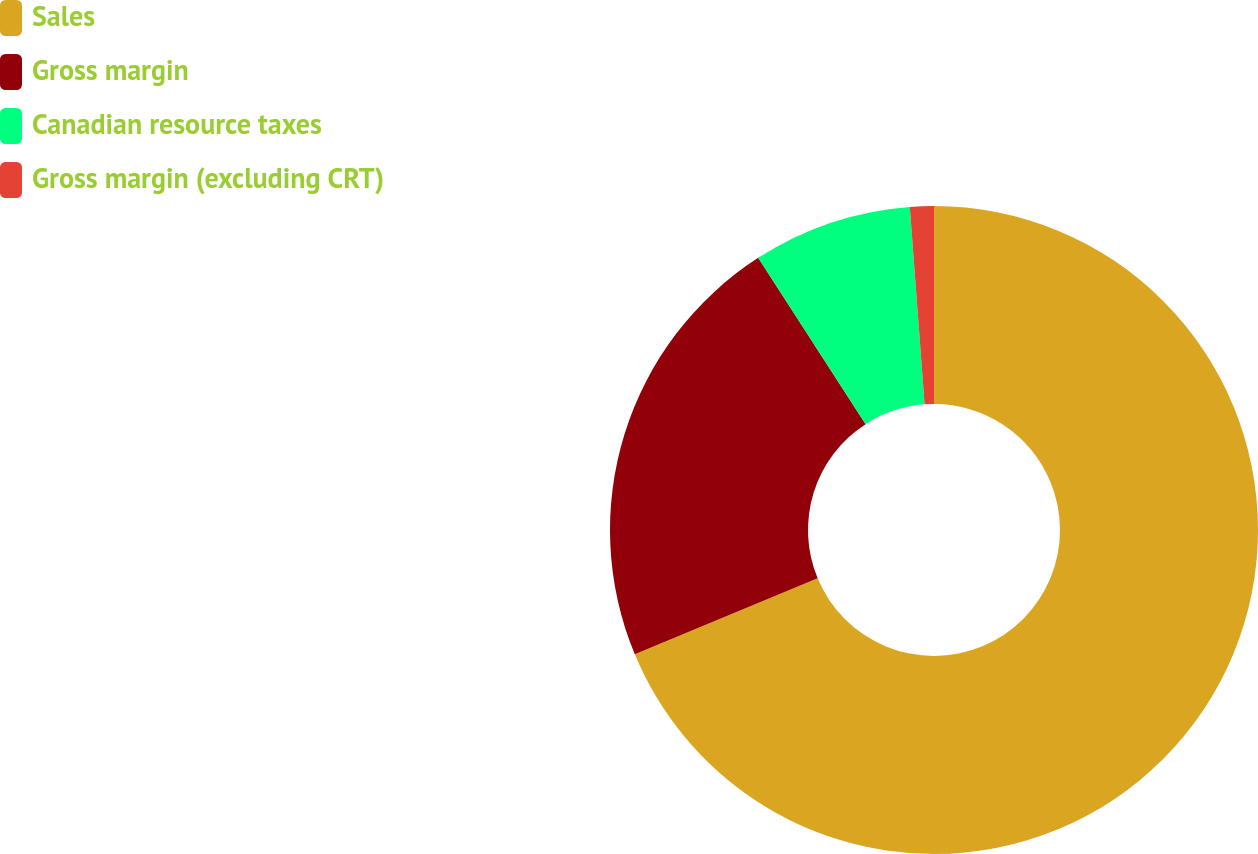Convert chart. <chart><loc_0><loc_0><loc_500><loc_500><pie_chart><fcel>Sales<fcel>Gross margin<fcel>Canadian resource taxes<fcel>Gross margin (excluding CRT)<nl><fcel>68.73%<fcel>22.14%<fcel>7.94%<fcel>1.19%<nl></chart> 